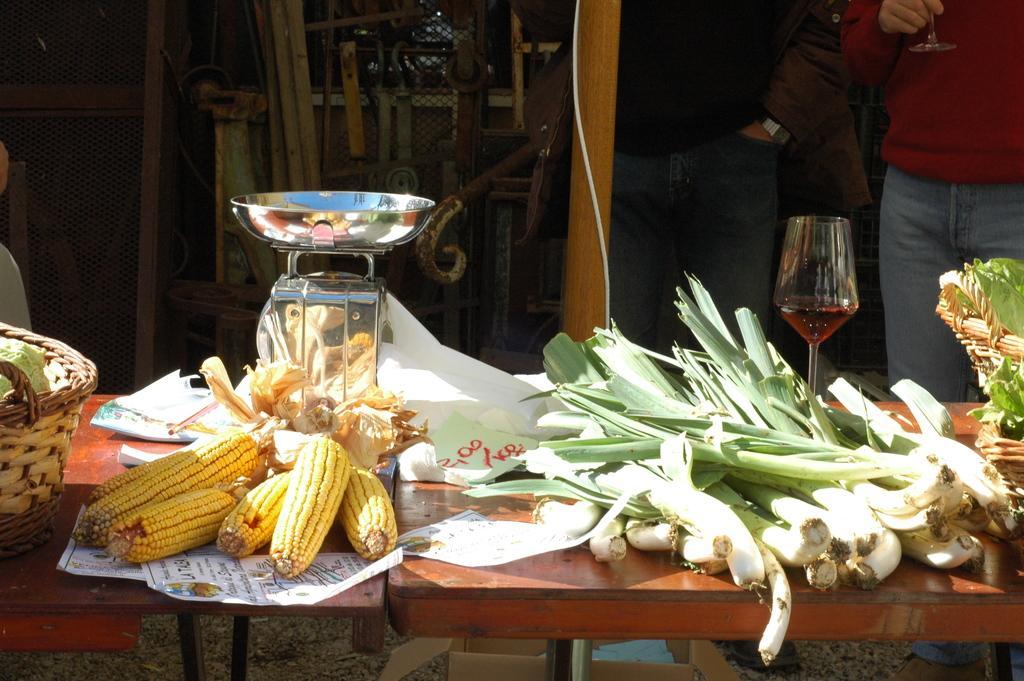In one or two sentences, can you explain what this image depicts? In this image we can see the persons standing near the table and holding an object. On the table there are baskets, vegetables, glass and few objects. In the background, we can see there are rods, fence and a few other objects. 